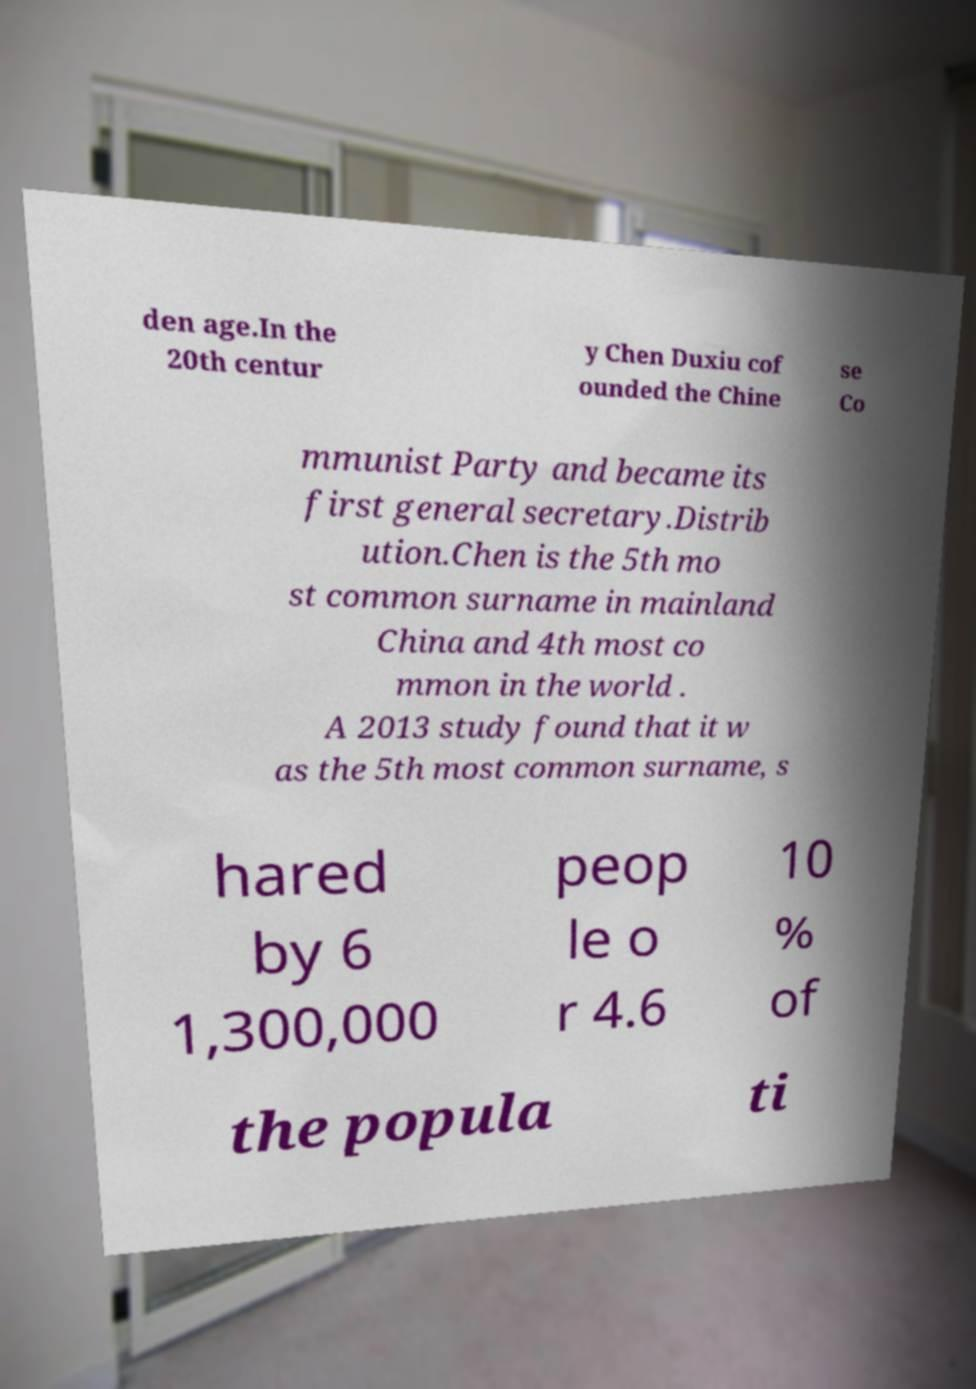For documentation purposes, I need the text within this image transcribed. Could you provide that? den age.In the 20th centur y Chen Duxiu cof ounded the Chine se Co mmunist Party and became its first general secretary.Distrib ution.Chen is the 5th mo st common surname in mainland China and 4th most co mmon in the world . A 2013 study found that it w as the 5th most common surname, s hared by 6 1,300,000 peop le o r 4.6 10 % of the popula ti 